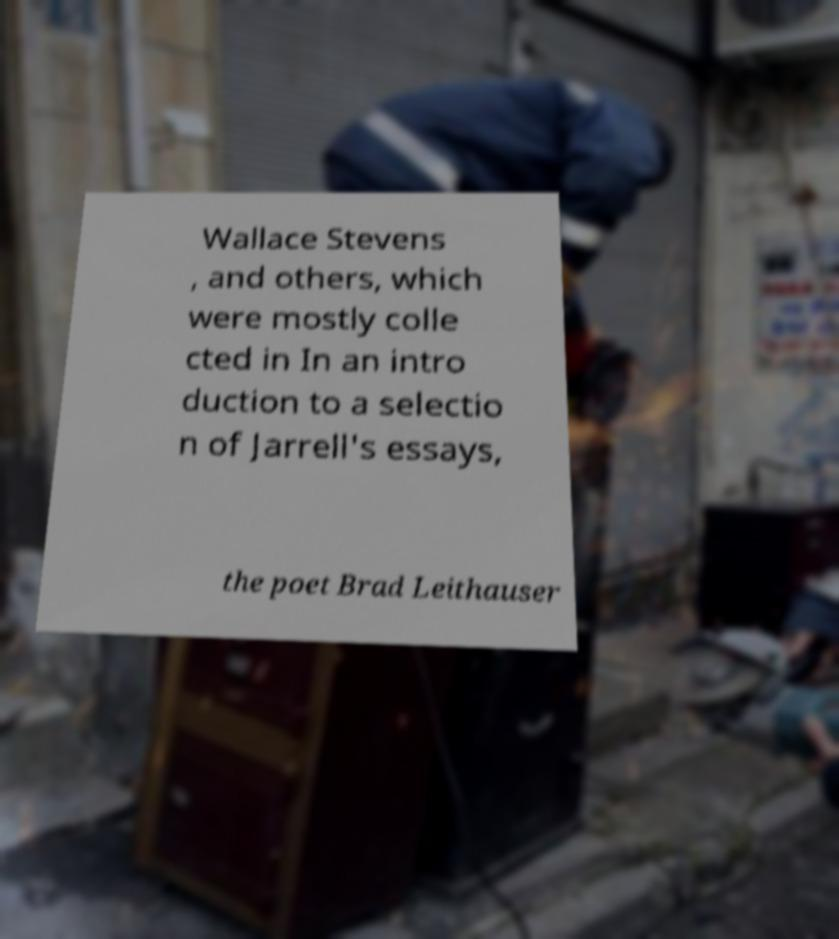Could you assist in decoding the text presented in this image and type it out clearly? Wallace Stevens , and others, which were mostly colle cted in In an intro duction to a selectio n of Jarrell's essays, the poet Brad Leithauser 